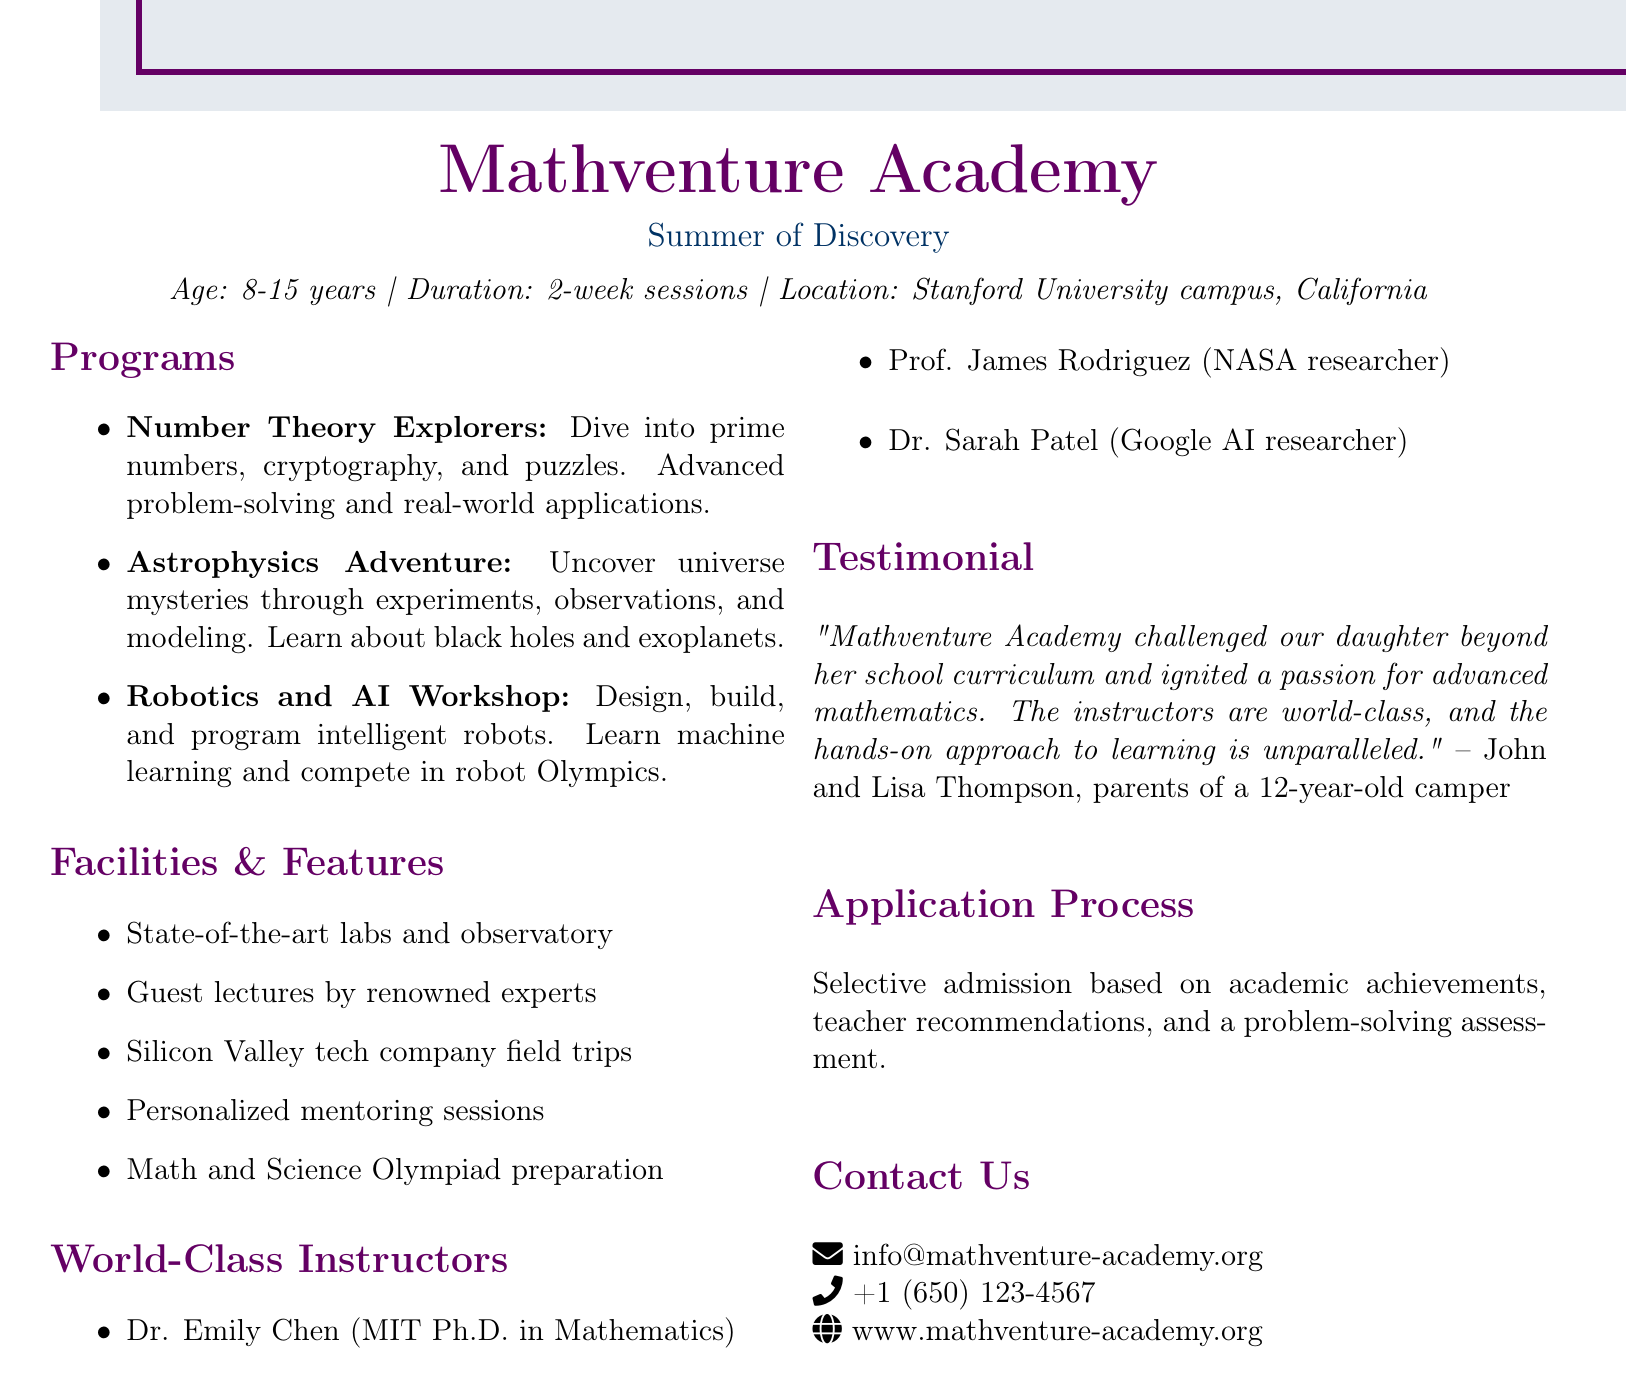What age group is the camp for? The age group for the camp is specified as 8-15 years.
Answer: 8-15 years What is the location of Mathventure Academy? The document mentions that the camp is located at Stanford University campus, California.
Answer: Stanford University campus, California Which course focuses on robotic design? The course that focuses on robotic design is the Robotics and AI Workshop.
Answer: Robotics and AI Workshop Who is a world-class instructor with a Ph.D. in Mathematics? Dr. Emily Chen is indicated as a world-class instructor with a Ph.D. in Mathematics from MIT.
Answer: Dr. Emily Chen What is the duration of each session? The document states that each session lasts for 2 weeks.
Answer: 2 weeks What type of admission process does the academy use? The academy uses selective admission based on academic achievements, teacher recommendations, and a problem-solving assessment.
Answer: Selective admission How do parents describe the academy's approach? The testimonial describes the academy's approach as hands-on and unparalleled.
Answer: Hands-on and unparalleled What is one of the features available at the academy? One feature available at the academy is state-of-the-art labs and observatory.
Answer: State-of-the-art labs and observatory Which famous space organization is associated with one of the instructors? NASA is associated with Prof. James Rodriguez, one of the instructors.
Answer: NASA 